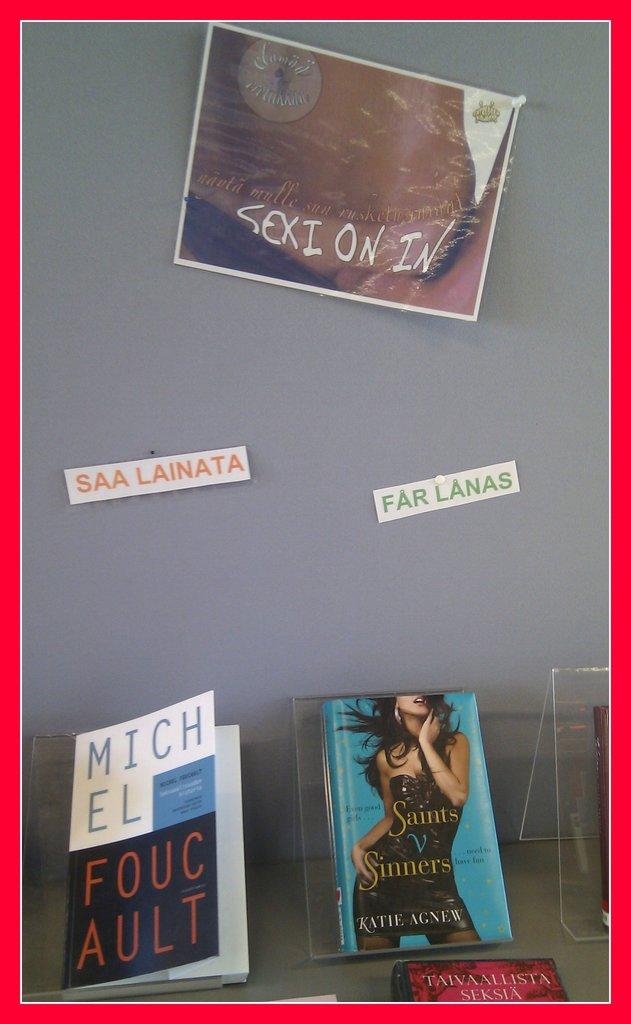What is the title of the book with the woman on the cover?
Make the answer very short. Saints v sinners. According to the cover, who are the saints in competition with?
Offer a terse response. Sinners. 